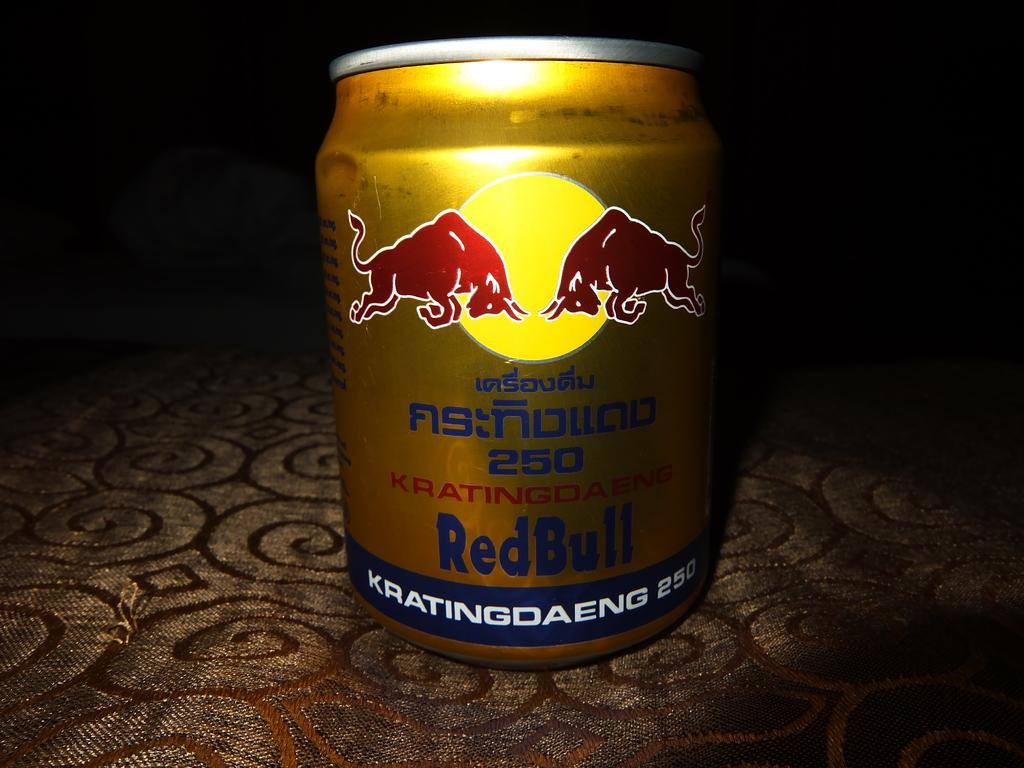<image>
Describe the image concisely. A gold can of RedBull includes text in a language other than English. 